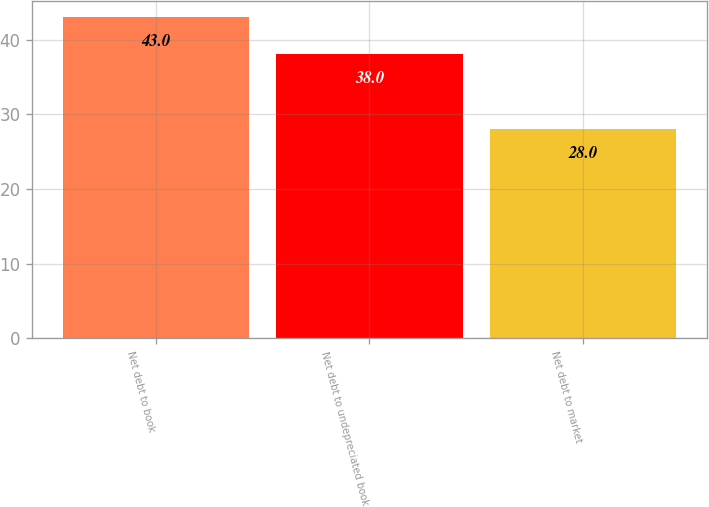Convert chart to OTSL. <chart><loc_0><loc_0><loc_500><loc_500><bar_chart><fcel>Net debt to book<fcel>Net debt to undepreciated book<fcel>Net debt to market<nl><fcel>43<fcel>38<fcel>28<nl></chart> 